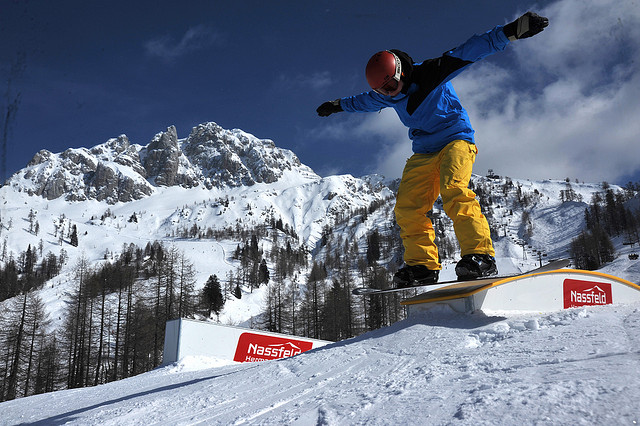If the snowboarder was holding a flag, where would it likely be in the image? If the snowboarder was holding a flag, considering their posture and position on the snowboard, it would likely be raised above their head in one of their outstretched hands, adding flair to their performance. 